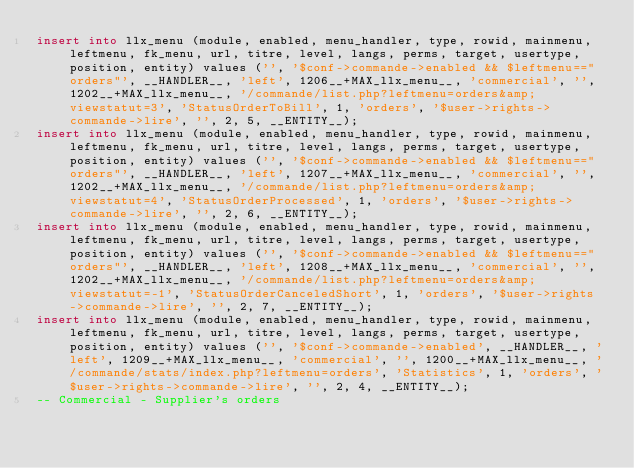<code> <loc_0><loc_0><loc_500><loc_500><_SQL_>insert into llx_menu (module, enabled, menu_handler, type, rowid, mainmenu, leftmenu, fk_menu, url, titre, level, langs, perms, target, usertype, position, entity) values ('', '$conf->commande->enabled && $leftmenu=="orders"', __HANDLER__, 'left', 1206__+MAX_llx_menu__, 'commercial', '', 1202__+MAX_llx_menu__, '/commande/list.php?leftmenu=orders&amp;viewstatut=3', 'StatusOrderToBill', 1, 'orders', '$user->rights->commande->lire', '', 2, 5, __ENTITY__);
insert into llx_menu (module, enabled, menu_handler, type, rowid, mainmenu, leftmenu, fk_menu, url, titre, level, langs, perms, target, usertype, position, entity) values ('', '$conf->commande->enabled && $leftmenu=="orders"', __HANDLER__, 'left', 1207__+MAX_llx_menu__, 'commercial', '', 1202__+MAX_llx_menu__, '/commande/list.php?leftmenu=orders&amp;viewstatut=4', 'StatusOrderProcessed', 1, 'orders', '$user->rights->commande->lire', '', 2, 6, __ENTITY__);
insert into llx_menu (module, enabled, menu_handler, type, rowid, mainmenu, leftmenu, fk_menu, url, titre, level, langs, perms, target, usertype, position, entity) values ('', '$conf->commande->enabled && $leftmenu=="orders"', __HANDLER__, 'left', 1208__+MAX_llx_menu__, 'commercial', '', 1202__+MAX_llx_menu__, '/commande/list.php?leftmenu=orders&amp;viewstatut=-1', 'StatusOrderCanceledShort', 1, 'orders', '$user->rights->commande->lire', '', 2, 7, __ENTITY__);
insert into llx_menu (module, enabled, menu_handler, type, rowid, mainmenu, leftmenu, fk_menu, url, titre, level, langs, perms, target, usertype, position, entity) values ('', '$conf->commande->enabled', __HANDLER__, 'left', 1209__+MAX_llx_menu__, 'commercial', '', 1200__+MAX_llx_menu__, '/commande/stats/index.php?leftmenu=orders', 'Statistics', 1, 'orders', '$user->rights->commande->lire', '', 2, 4, __ENTITY__);
-- Commercial - Supplier's orders</code> 